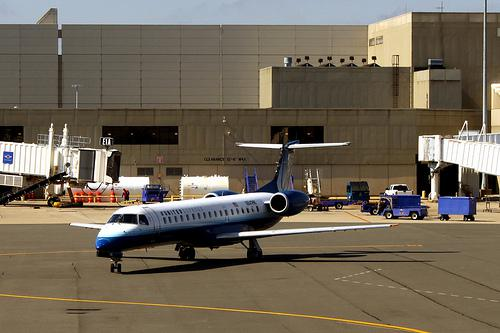Question: when did the dog arrive?
Choices:
A. 10 minutes ago.
B. This afternoon.
C. No dog.
D. At noon.
Answer with the letter. Answer: C Question: what color is the building?
Choices:
A. Black.
B. White.
C. Tan.
D. Silver.
Answer with the letter. Answer: C Question: what color are the service vehicles?
Choices:
A. White.
B. Blue.
C. Yellow.
D. Red.
Answer with the letter. Answer: B Question: how many planes are there?
Choices:
A. Two.
B. Three.
C. Four.
D. One.
Answer with the letter. Answer: D 